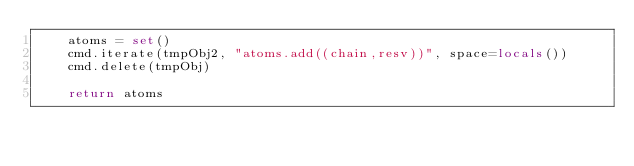<code> <loc_0><loc_0><loc_500><loc_500><_Python_>    atoms = set()
    cmd.iterate(tmpObj2, "atoms.add((chain,resv))", space=locals())
    cmd.delete(tmpObj)

    return atoms
</code> 